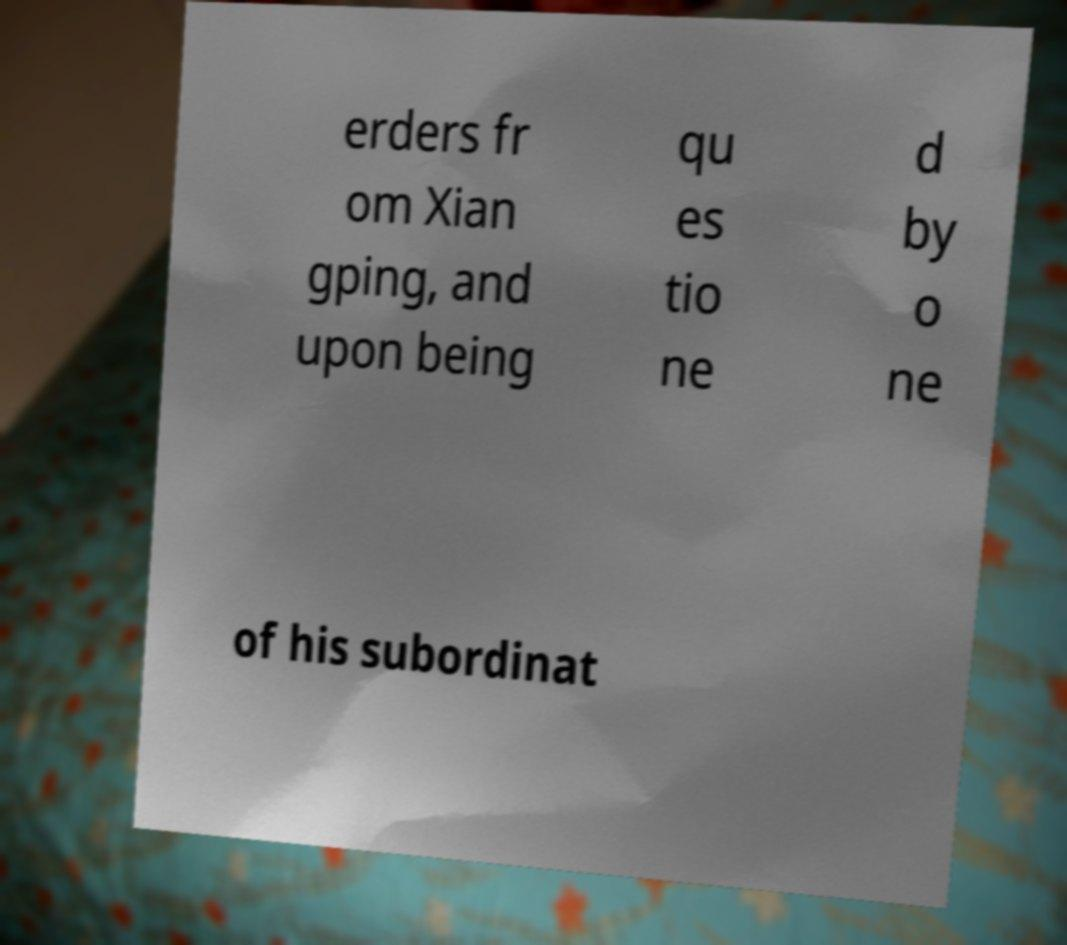Could you extract and type out the text from this image? erders fr om Xian gping, and upon being qu es tio ne d by o ne of his subordinat 